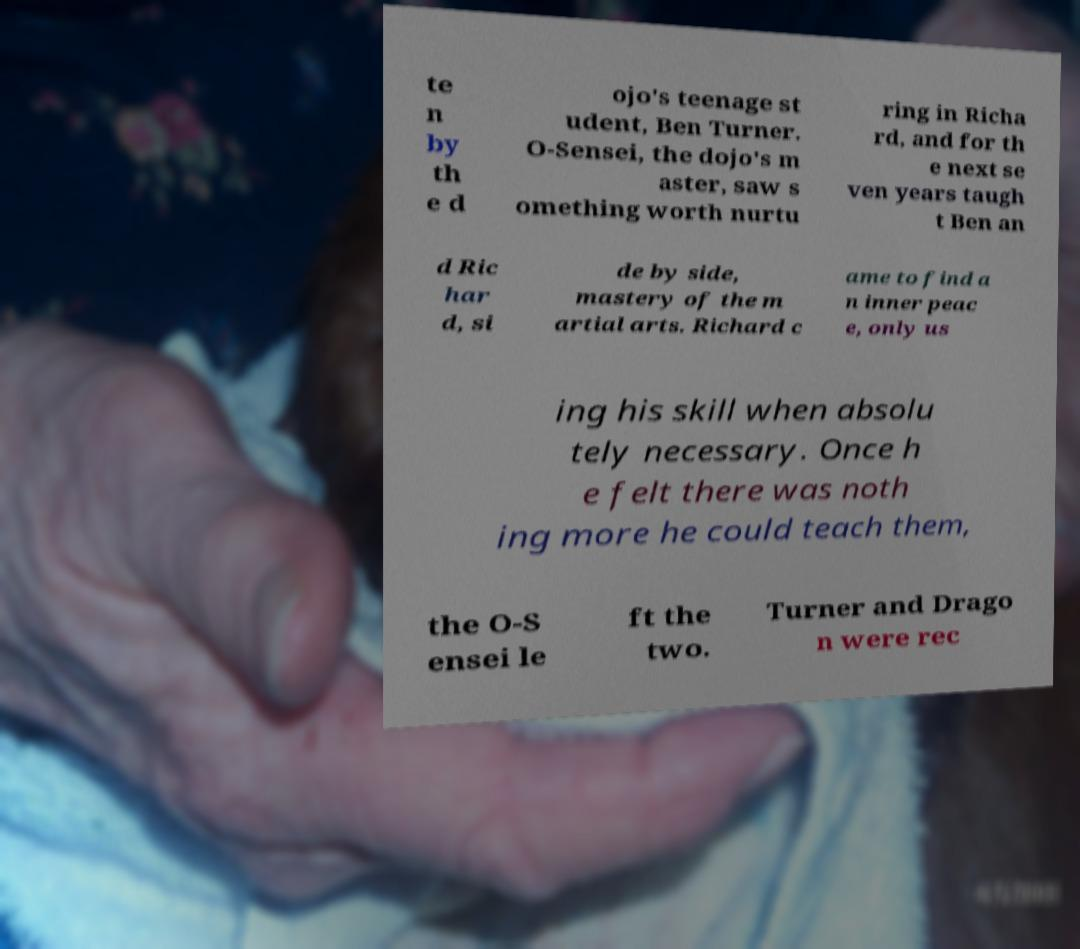There's text embedded in this image that I need extracted. Can you transcribe it verbatim? te n by th e d ojo's teenage st udent, Ben Turner. O-Sensei, the dojo's m aster, saw s omething worth nurtu ring in Richa rd, and for th e next se ven years taugh t Ben an d Ric har d, si de by side, mastery of the m artial arts. Richard c ame to find a n inner peac e, only us ing his skill when absolu tely necessary. Once h e felt there was noth ing more he could teach them, the O-S ensei le ft the two. Turner and Drago n were rec 